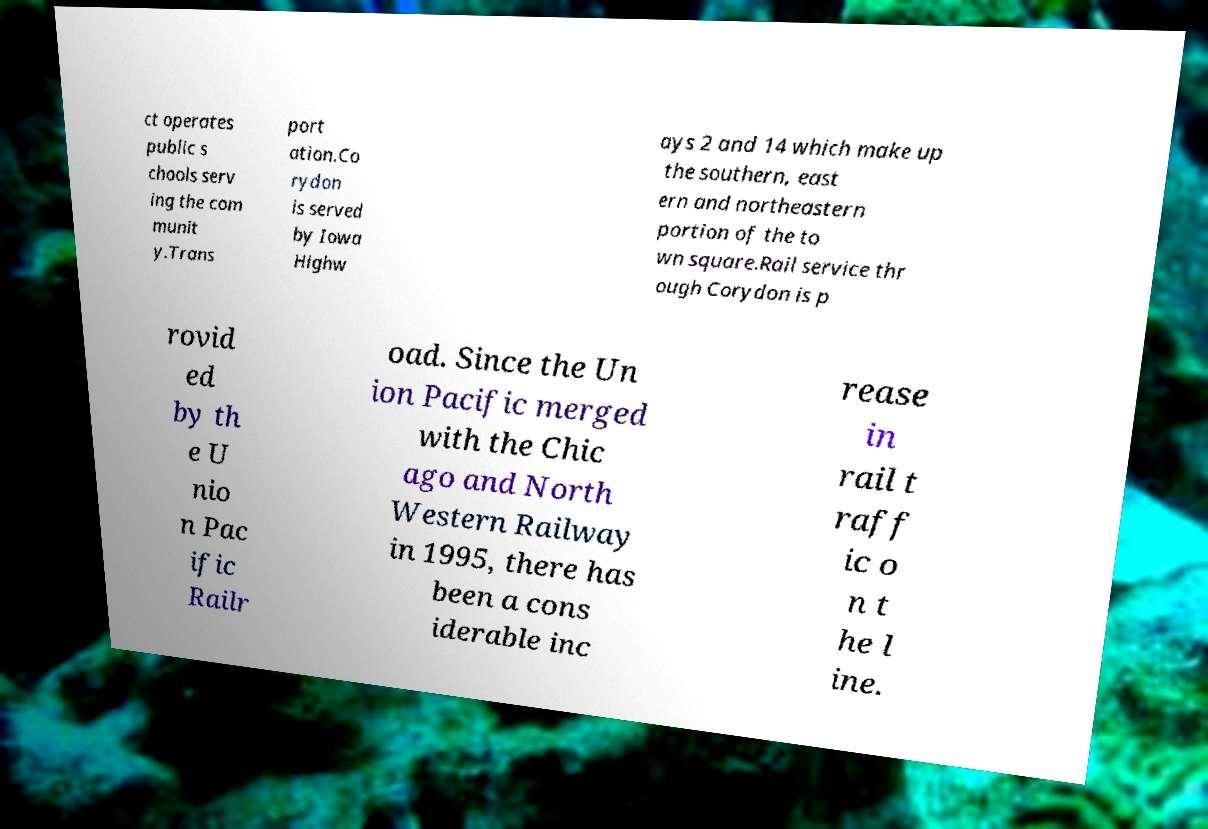Please read and relay the text visible in this image. What does it say? ct operates public s chools serv ing the com munit y.Trans port ation.Co rydon is served by Iowa Highw ays 2 and 14 which make up the southern, east ern and northeastern portion of the to wn square.Rail service thr ough Corydon is p rovid ed by th e U nio n Pac ific Railr oad. Since the Un ion Pacific merged with the Chic ago and North Western Railway in 1995, there has been a cons iderable inc rease in rail t raff ic o n t he l ine. 